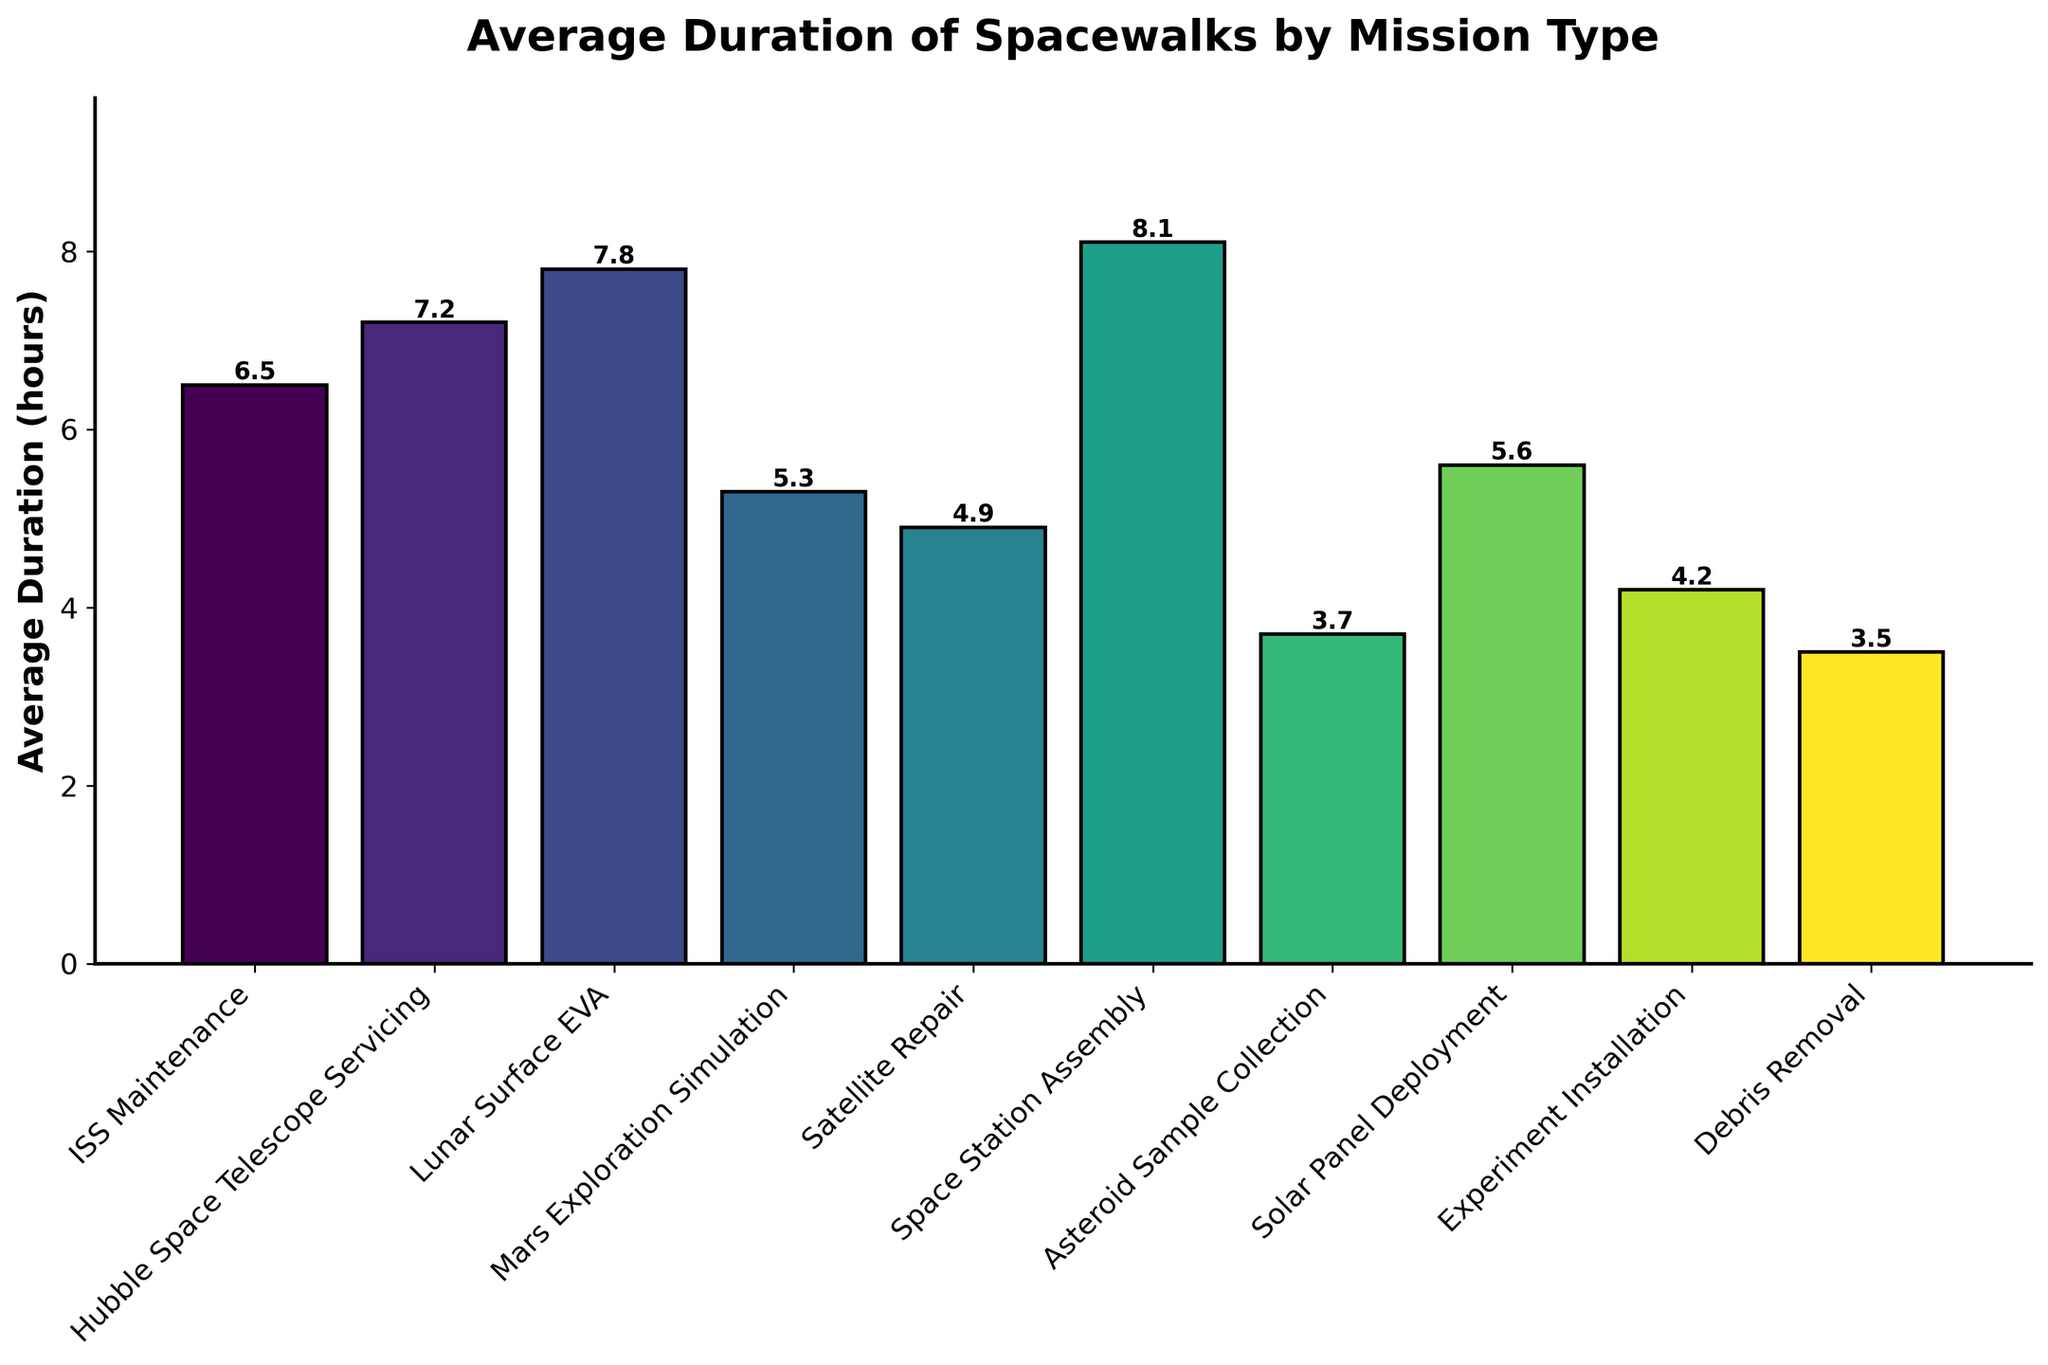Which mission type has the longest average duration of spacewalks? The bar representing "Space Station Assembly" is the tallest, indicating it has the highest value.
Answer: Space Station Assembly Which mission type has the shortest average duration of spacewalks? The bar representing "Debris Removal" is the shortest, indicating it has the lowest value.
Answer: Debris Removal How much longer, on average, are spacewalks for the "Lunar Surface EVA" compared to "Debris Removal"? The average duration for "Lunar Surface EVA" is 7.8 hours and for "Debris Removal" is 3.5 hours. The difference is 7.8 - 3.5 = 4.3 hours.
Answer: 4.3 hours Which mission types have an average duration of spacewalks longer than 5 hours? The bars above the 5-hour mark are "ISS Maintenance," "Hubble Space Telescope Servicing," "Lunar Surface EVA," "Space Station Assembly," and "Solar Panel Deployment."
Answer: ISS Maintenance, Hubble Space Telescope Servicing, Lunar Surface EVA, Space Station Assembly, Solar Panel Deployment What is the combined average duration of spacewalks for "Satellite Repair" and "Asteroid Sample Collection"? The average duration for "Satellite Repair" is 4.9 hours and for "Asteroid Sample Collection" is 3.7 hours. The combined duration is 4.9 + 3.7 = 8.6 hours.
Answer: 8.6 hours How many mission types have an average duration of spacewalks between 4 hours and 6 hours? The bars that fall within this range correspond to "Satellite Repair," "Asteroid Sample Collection," "Solar Panel Deployment," and "Experiment Installation." This includes 4 mission types.
Answer: 4 What is the difference in average duration of spacewalks between "ISS Maintenance" and "Solar Panel Deployment"? The average duration for "ISS Maintenance" is 6.5 hours and for "Solar Panel Deployment" is 5.6 hours. The difference is 6.5 - 5.6 = 0.9 hours.
Answer: 0.9 hours Which mission type related to space exploration has the higher average duration, "Lunar Surface EVA" or "Mars Exploration Simulation"? The average duration for "Lunar Surface EVA" is 7.8 hours, and for "Mars Exploration Simulation" it is 5.3 hours. Therefore, "Lunar Surface EVA" has a higher average duration.
Answer: Lunar Surface EVA What is the average duration of spacewalks for all mission types combined? Add up all the average durations: 6.5 + 7.2 + 7.8 + 5.3 + 4.9 + 8.1 + 3.7 + 5.6 + 4.2 + 3.5 = 56.8 hours. There are 10 mission types, so the overall average is 56.8 / 10 = 5.68 hours.
Answer: 5.68 hours 